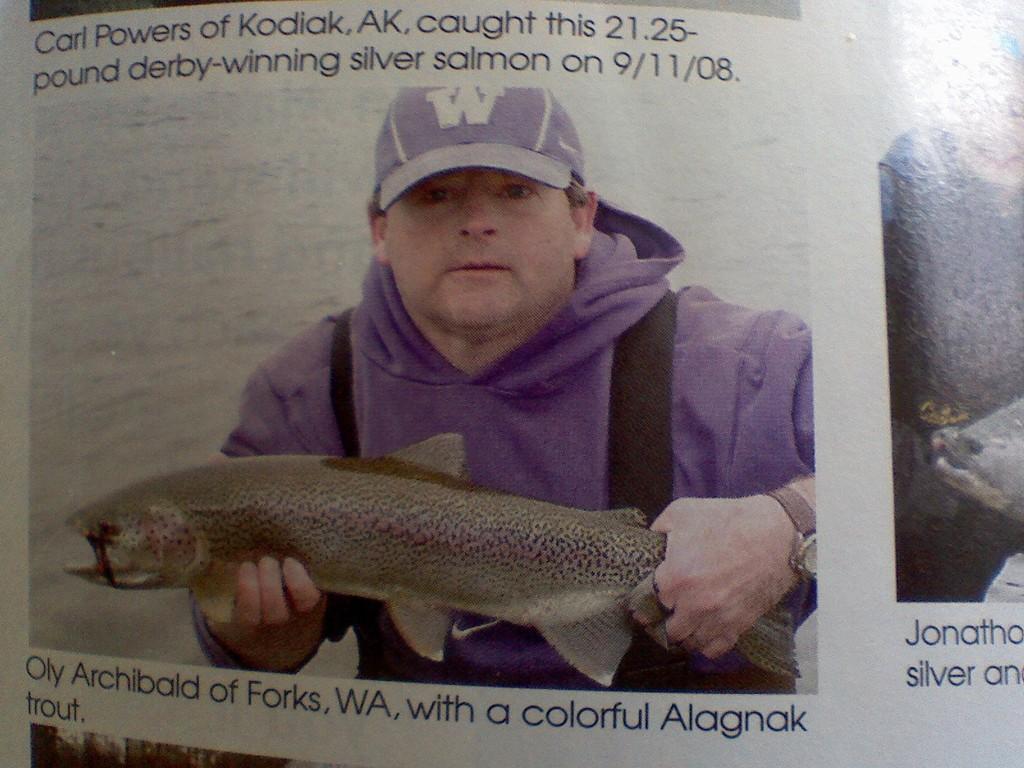In one or two sentences, can you explain what this image depicts? This image is taken from the article in which there is a man who is holding the fish. 